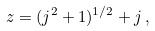<formula> <loc_0><loc_0><loc_500><loc_500>z = ( j ^ { 2 } + 1 ) ^ { 1 / 2 } + j \, ,</formula> 